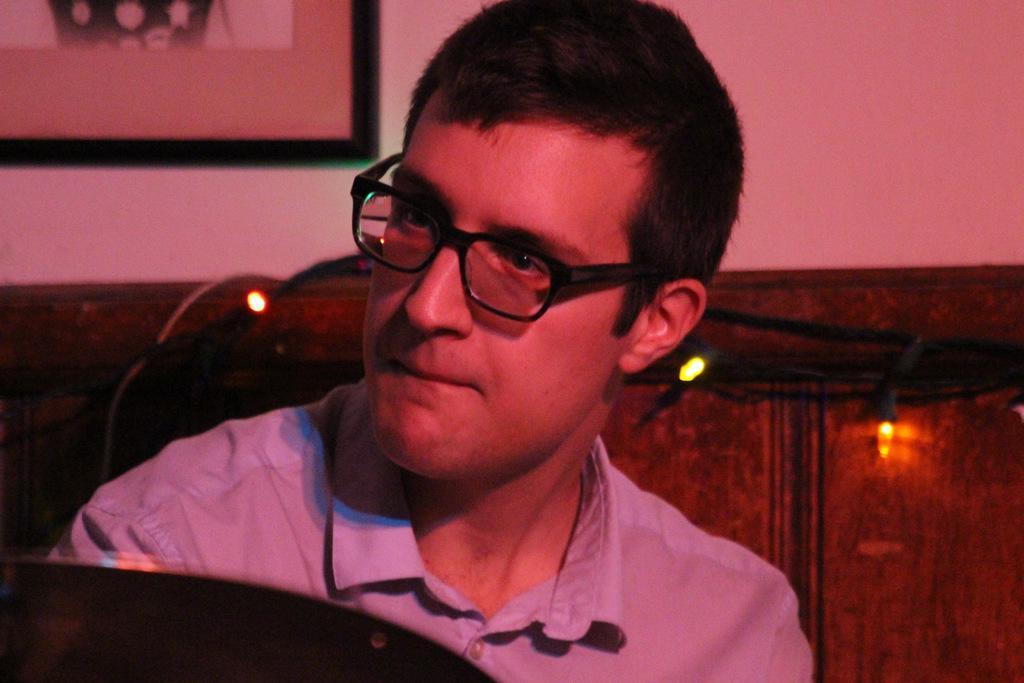Please provide a concise description of this image. The picture is taken inside a room. In the foreground of the picture there is a man wearing spectacles, behind him there are lights and an wooden object. At the top it is well, there is a frame to the wall. 